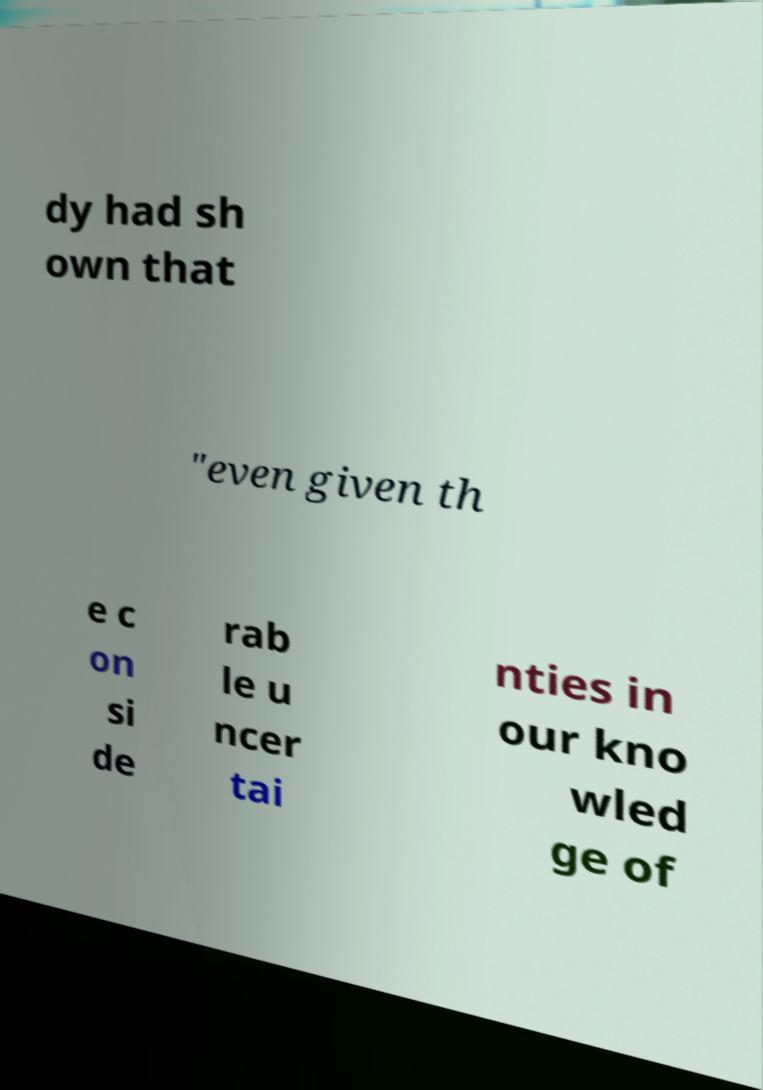Can you accurately transcribe the text from the provided image for me? dy had sh own that "even given th e c on si de rab le u ncer tai nties in our kno wled ge of 